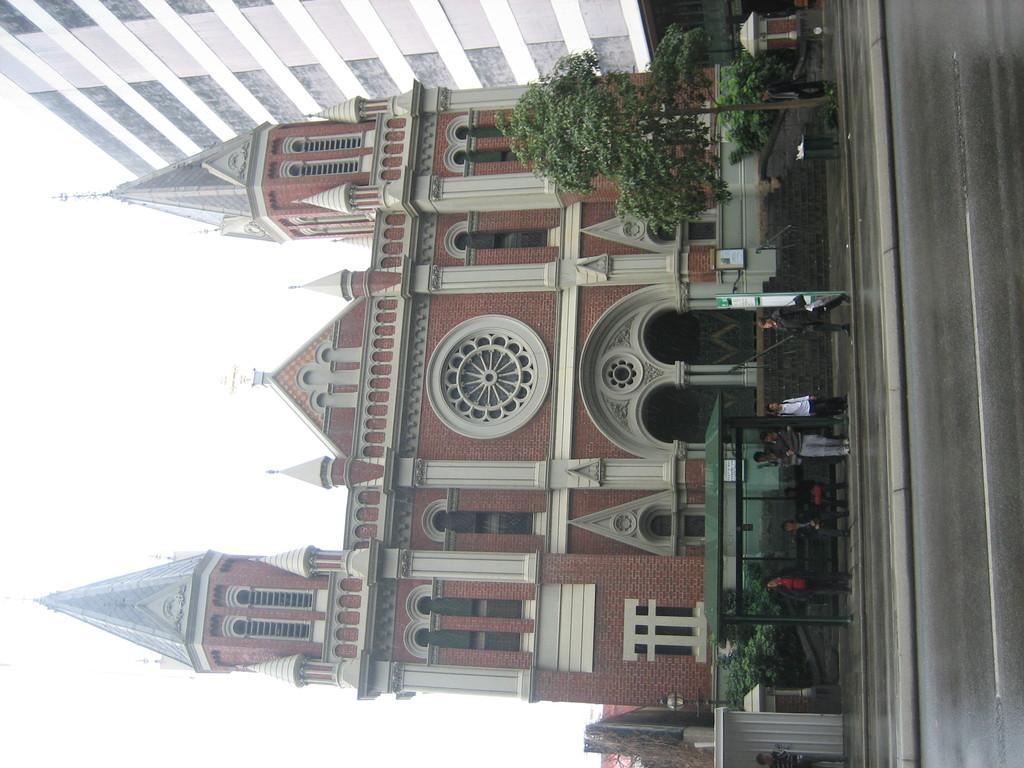Could you give a brief overview of what you see in this image? This image is taken outdoors. On the right side of the image there is a road and a sidewalk. On the left side of the image there is a sky. In the middle of the image there are two buildings with walls, windows, doors, roofs, steeples and carvings. There are a few trees and a few people are standing on the sidewalk. 